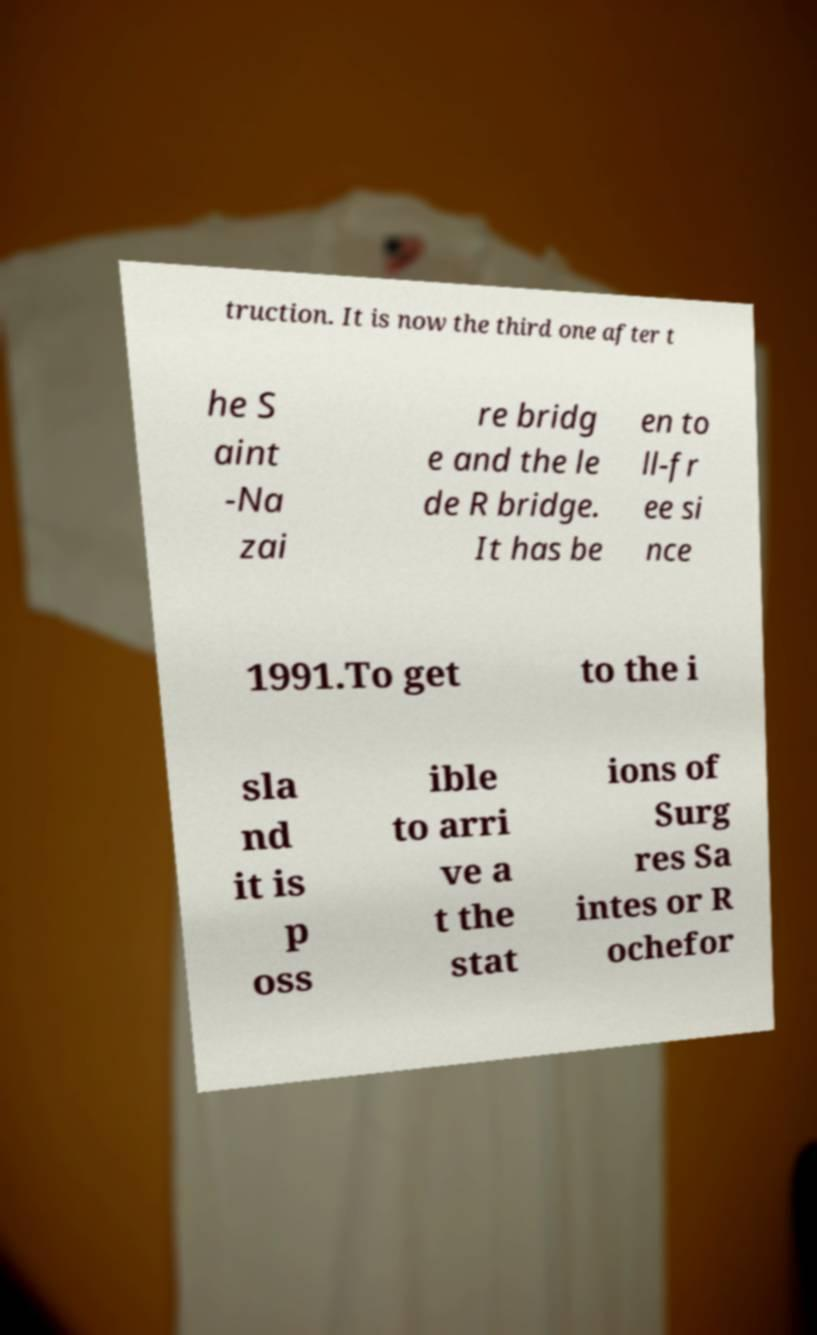There's text embedded in this image that I need extracted. Can you transcribe it verbatim? truction. It is now the third one after t he S aint -Na zai re bridg e and the le de R bridge. It has be en to ll-fr ee si nce 1991.To get to the i sla nd it is p oss ible to arri ve a t the stat ions of Surg res Sa intes or R ochefor 